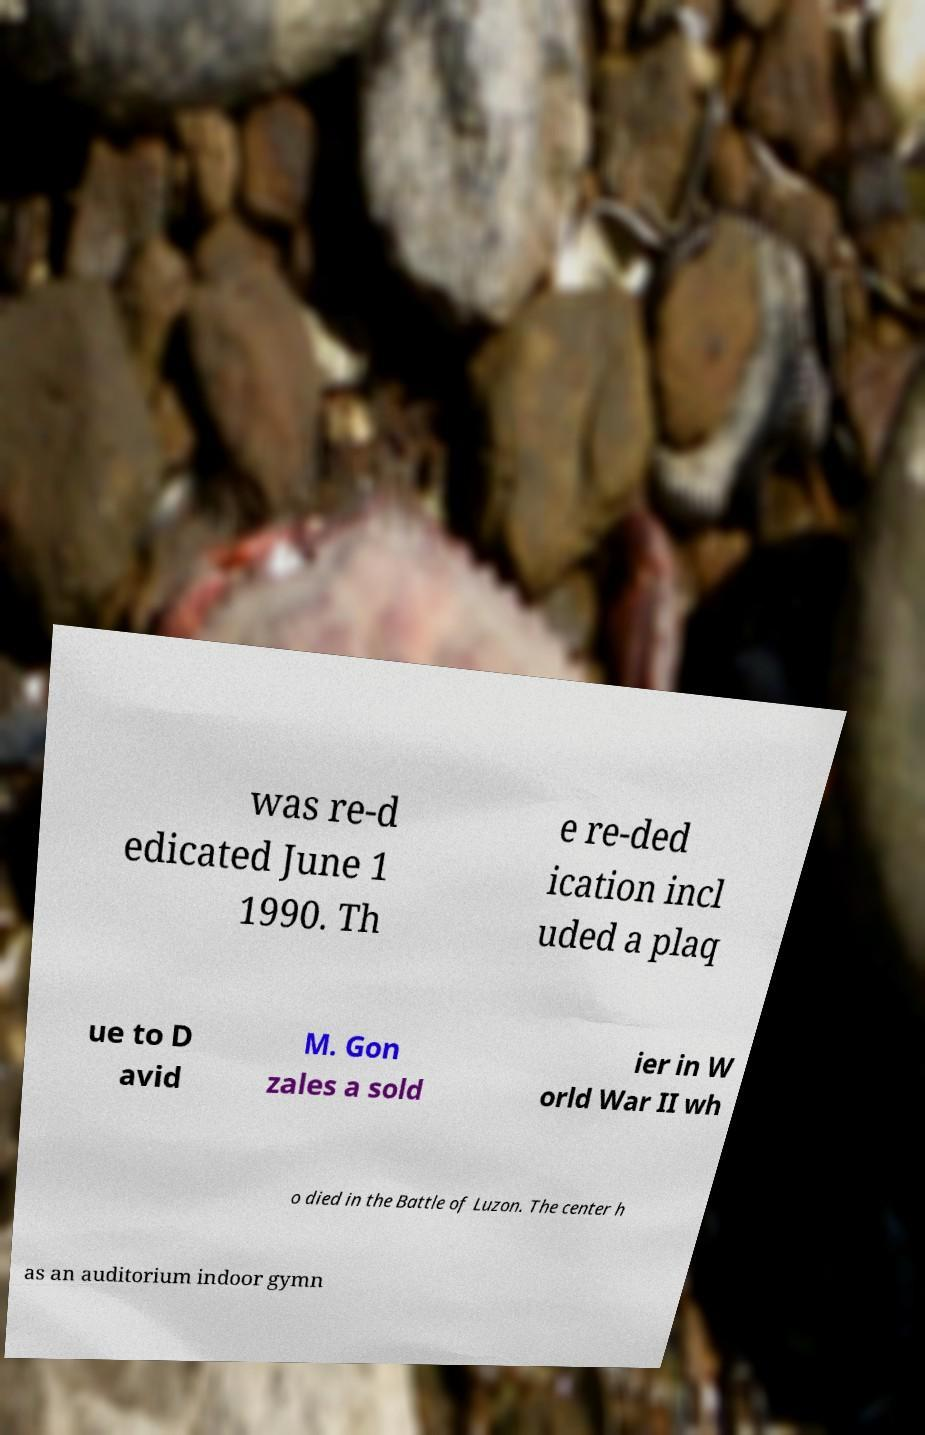There's text embedded in this image that I need extracted. Can you transcribe it verbatim? was re-d edicated June 1 1990. Th e re-ded ication incl uded a plaq ue to D avid M. Gon zales a sold ier in W orld War II wh o died in the Battle of Luzon. The center h as an auditorium indoor gymn 